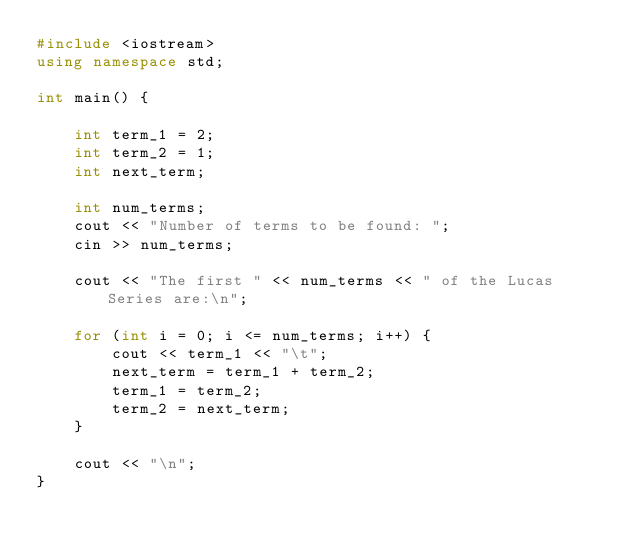Convert code to text. <code><loc_0><loc_0><loc_500><loc_500><_C++_>#include <iostream>
using namespace std;

int main() {

    int term_1 = 2;
    int term_2 = 1;
    int next_term;
    
    int num_terms;  
    cout << "Number of terms to be found: ";
    cin >> num_terms;

    cout << "The first " << num_terms << " of the Lucas Series are:\n";

    for (int i = 0; i <= num_terms; i++) {
        cout << term_1 << "\t";
        next_term = term_1 + term_2;
        term_1 = term_2;
        term_2 = next_term;
    }
    
    cout << "\n";
}</code> 